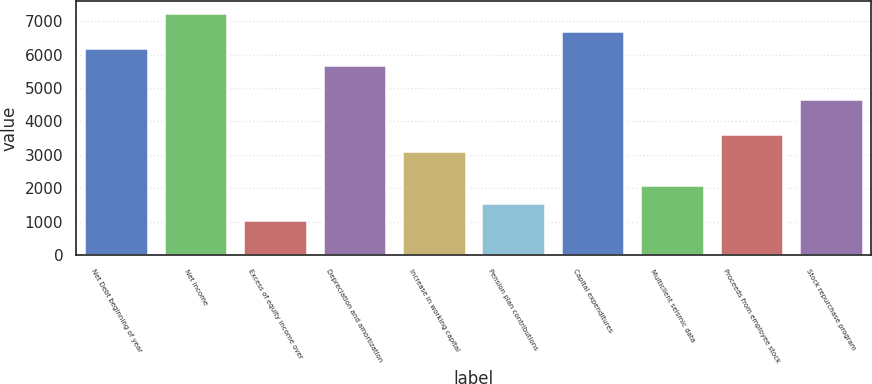Convert chart. <chart><loc_0><loc_0><loc_500><loc_500><bar_chart><fcel>Net Debt beginning of year<fcel>Net income<fcel>Excess of equity income over<fcel>Depreciation and amortization<fcel>Increase in working capital<fcel>Pension plan contributions<fcel>Capital expenditures<fcel>Multiclient seismic data<fcel>Proceeds from employee stock<fcel>Stock repurchase program<nl><fcel>6208<fcel>7239<fcel>1053<fcel>5692.5<fcel>3115<fcel>1568.5<fcel>6723.5<fcel>2084<fcel>3630.5<fcel>4661.5<nl></chart> 